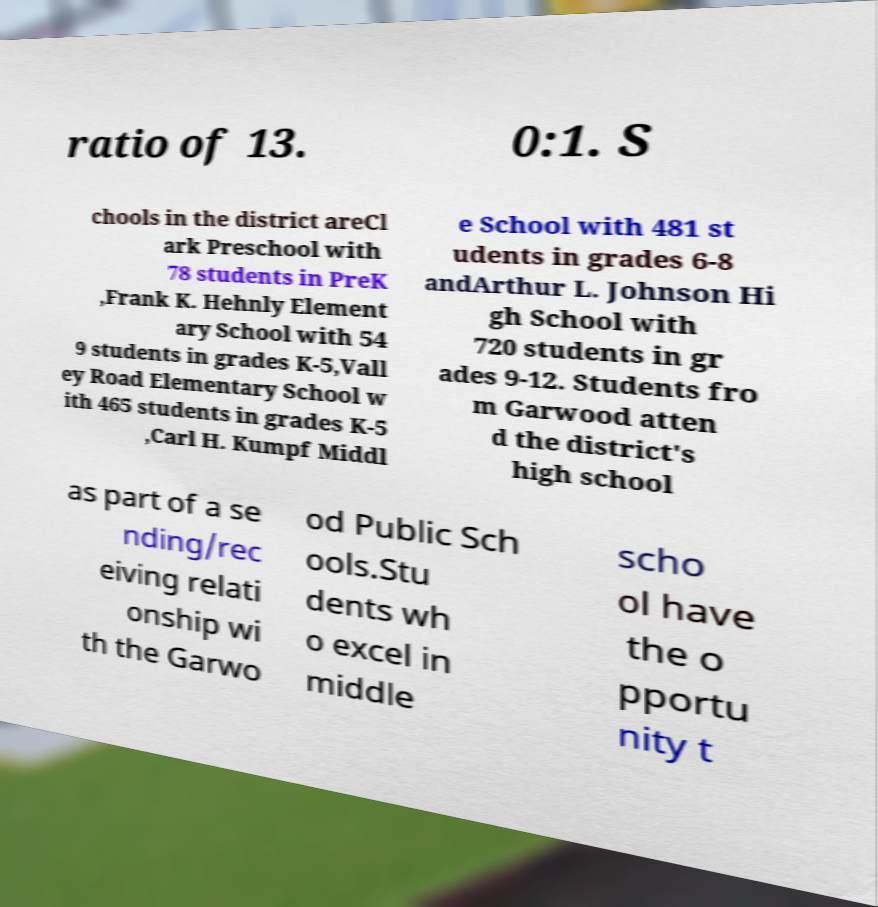What messages or text are displayed in this image? I need them in a readable, typed format. ratio of 13. 0:1. S chools in the district areCl ark Preschool with 78 students in PreK ,Frank K. Hehnly Element ary School with 54 9 students in grades K-5,Vall ey Road Elementary School w ith 465 students in grades K-5 ,Carl H. Kumpf Middl e School with 481 st udents in grades 6-8 andArthur L. Johnson Hi gh School with 720 students in gr ades 9-12. Students fro m Garwood atten d the district's high school as part of a se nding/rec eiving relati onship wi th the Garwo od Public Sch ools.Stu dents wh o excel in middle scho ol have the o pportu nity t 